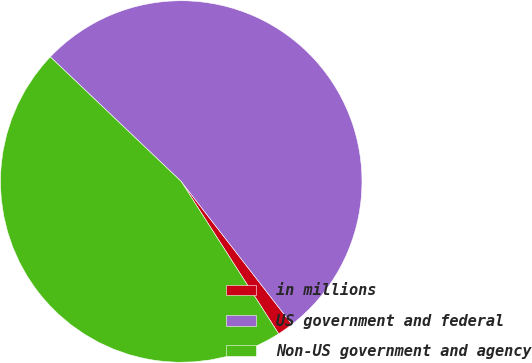Convert chart to OTSL. <chart><loc_0><loc_0><loc_500><loc_500><pie_chart><fcel>in millions<fcel>US government and federal<fcel>Non-US government and agency<nl><fcel>1.43%<fcel>52.4%<fcel>46.16%<nl></chart> 